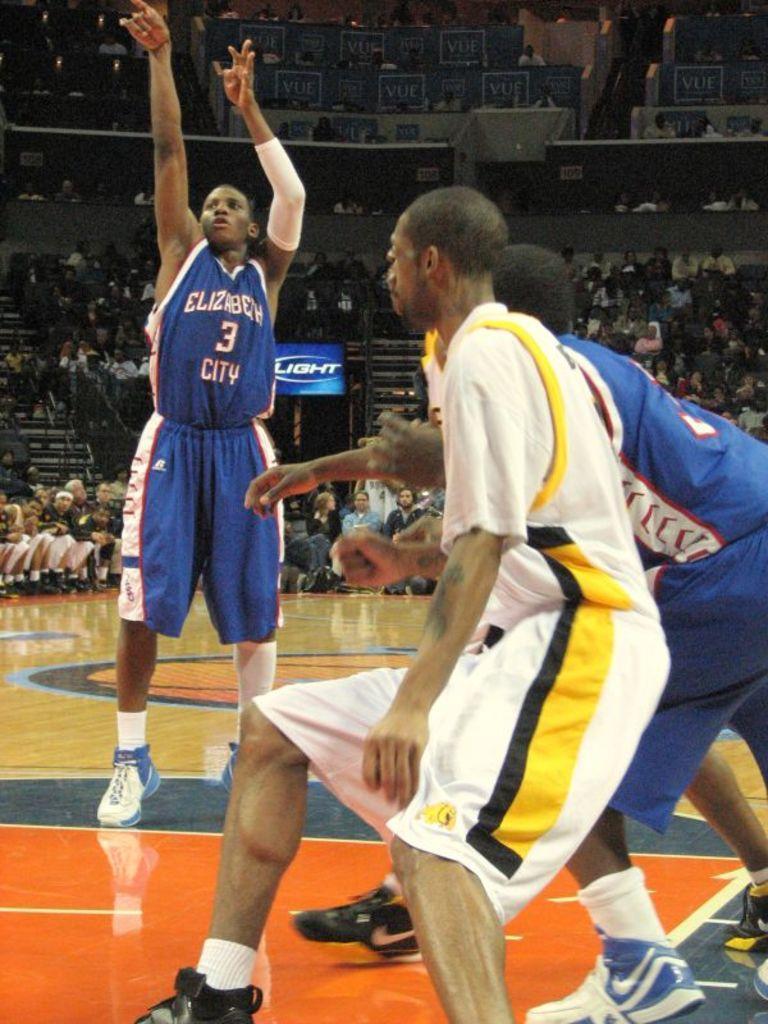How would you summarize this image in a sentence or two? In this picture we can see there are some people are playing on the path and the man is jumping. Behind the people there are boards, some people are sitting and other things. 